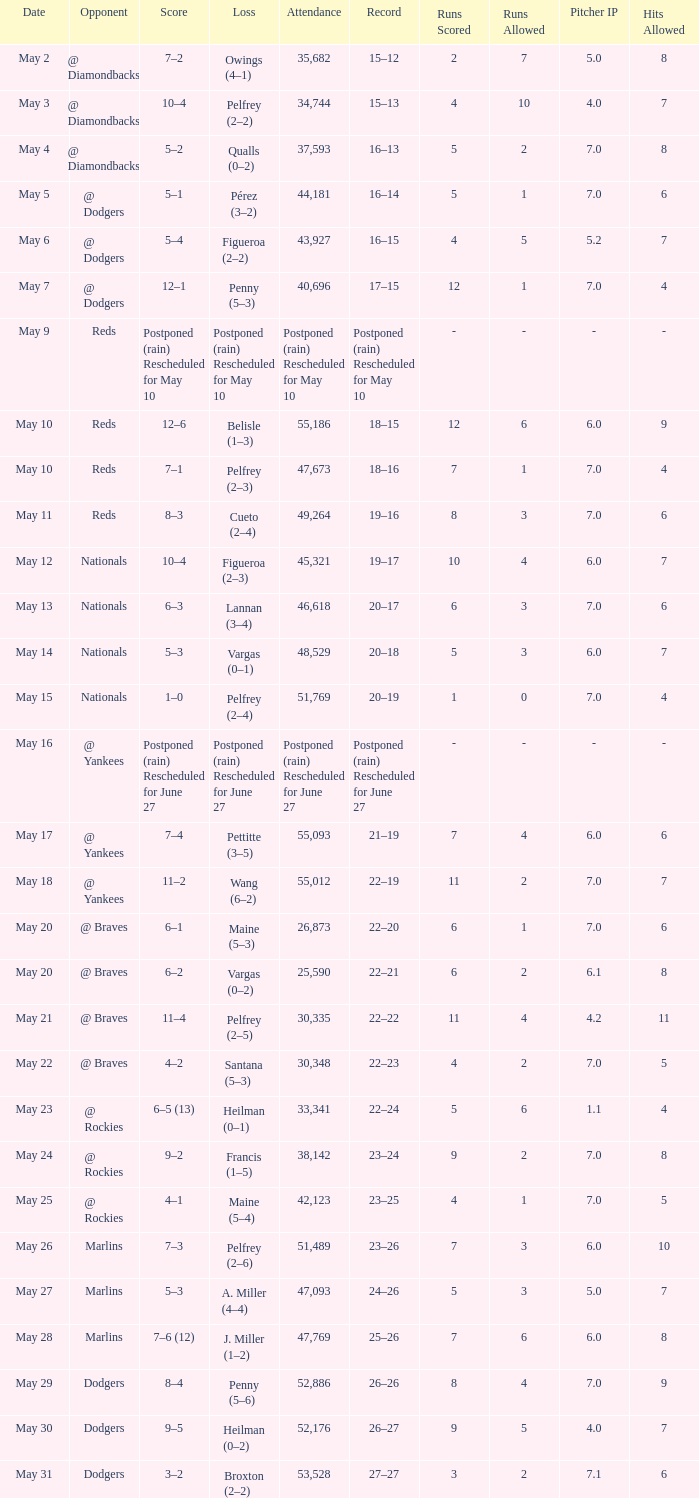Record of 19–16 occurred on what date? May 11. 